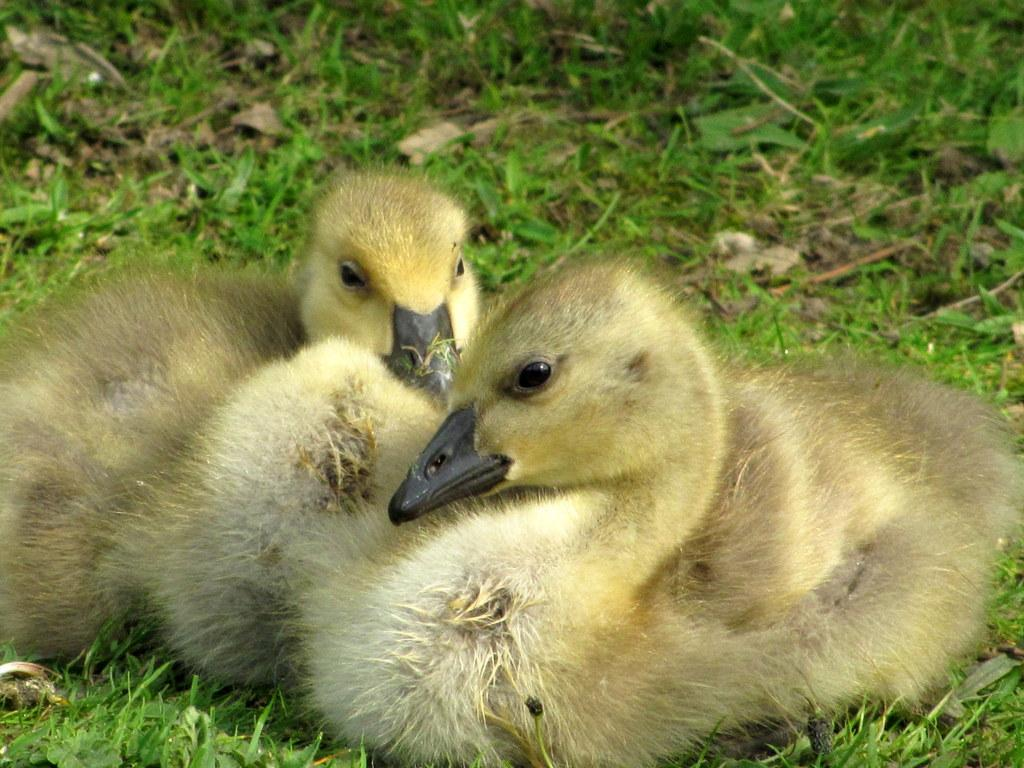What animals can be seen in the image? There are two ducks in the image. What type of vegetation is visible in the image? There is grass visible in the image. Can you find the receipt for the ducks' purchase in the image? There is no receipt present in the image. How many chickens are visible in the image? There are no chickens visible in the image; only two ducks are present. 